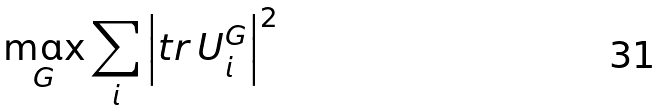<formula> <loc_0><loc_0><loc_500><loc_500>\max _ { G } \sum _ { i } \left | t r \, U _ { i } ^ { G } \right | ^ { 2 }</formula> 